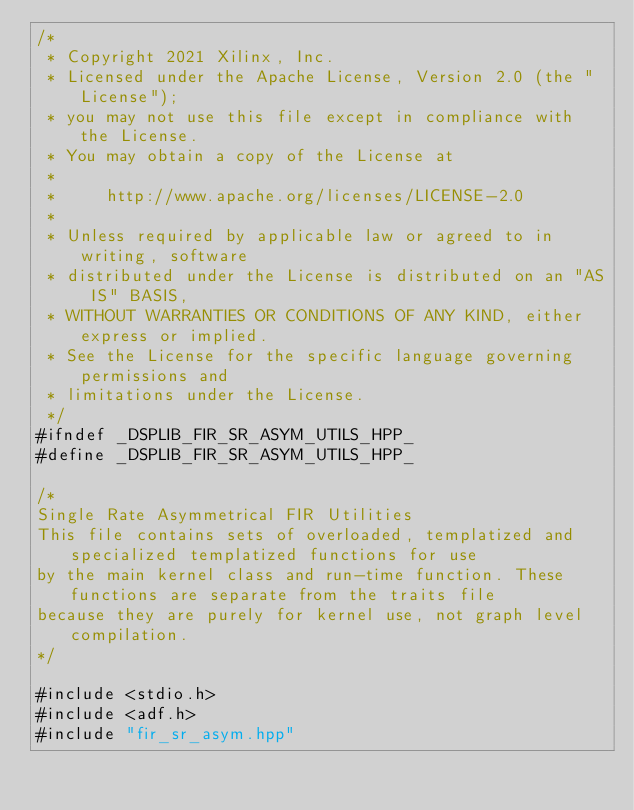<code> <loc_0><loc_0><loc_500><loc_500><_C++_>/*
 * Copyright 2021 Xilinx, Inc.
 * Licensed under the Apache License, Version 2.0 (the "License");
 * you may not use this file except in compliance with the License.
 * You may obtain a copy of the License at
 *
 *     http://www.apache.org/licenses/LICENSE-2.0
 *
 * Unless required by applicable law or agreed to in writing, software
 * distributed under the License is distributed on an "AS IS" BASIS,
 * WITHOUT WARRANTIES OR CONDITIONS OF ANY KIND, either express or implied.
 * See the License for the specific language governing permissions and
 * limitations under the License.
 */
#ifndef _DSPLIB_FIR_SR_ASYM_UTILS_HPP_
#define _DSPLIB_FIR_SR_ASYM_UTILS_HPP_

/*
Single Rate Asymmetrical FIR Utilities
This file contains sets of overloaded, templatized and specialized templatized functions for use
by the main kernel class and run-time function. These functions are separate from the traits file
because they are purely for kernel use, not graph level compilation.
*/

#include <stdio.h>
#include <adf.h>
#include "fir_sr_asym.hpp"
</code> 